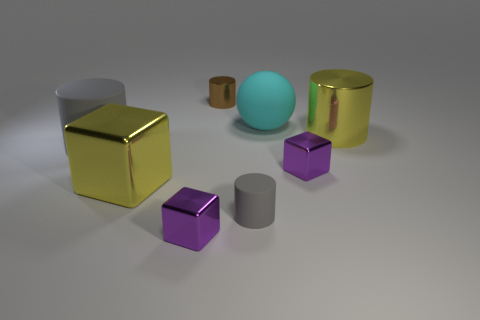Add 2 small gray matte cylinders. How many objects exist? 10 Subtract all cubes. How many objects are left? 5 Add 6 big cylinders. How many big cylinders are left? 8 Add 2 yellow shiny blocks. How many yellow shiny blocks exist? 3 Subtract 0 brown spheres. How many objects are left? 8 Subtract all large metallic cylinders. Subtract all large yellow metal cubes. How many objects are left? 6 